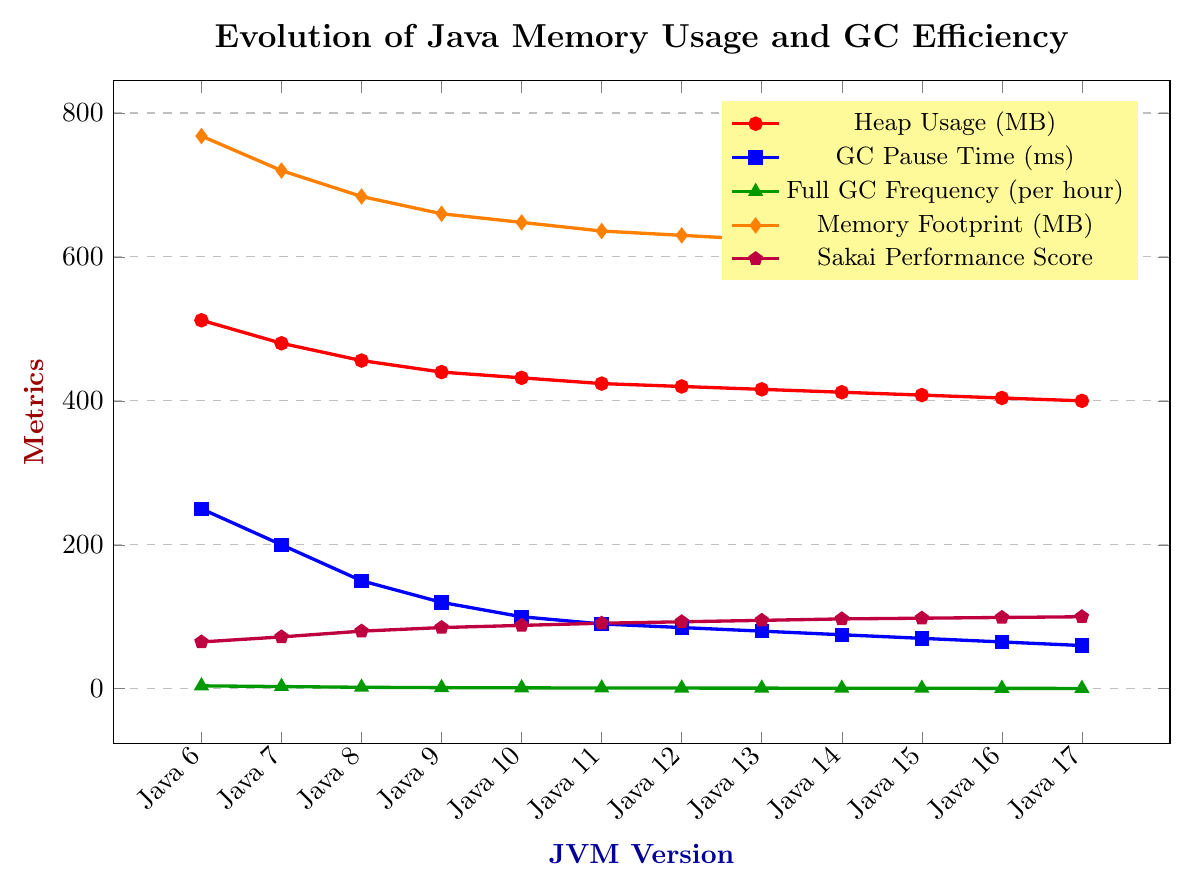What trend can be observed in heap usage across different JVM versions? The heap usage shows a consistent decreasing trend as the JVM version progresses from Java 6 to Java 17.
Answer: Decreasing trend Between which two consecutive JVM versions is the most significant drop in GC Pause Time observed? The most significant drop in GC Pause Time is observed between Java 7 and Java 8, where it decreases from 200 ms to 150 ms.
Answer: Between Java 7 and Java 8 What is the difference in Sakai Performance Score between Java 8 and Java 17? The Sakai Performance Score for Java 8 is 80 and for Java 17 is 100. The difference is 100 - 80 = 20.
Answer: 20 Which JVM version has the highest Full GC Frequency per hour, and what is that frequency? The highest Full GC Frequency per hour is observed in Java 6, which is 4.
Answer: Java 6, 4 How does the Memory Footprint change from Java 6 to Java 17? The Memory Footprint consistently decreases from 768 MB in Java 6 to 600 MB in Java 17.
Answer: Decreases Compare the GC Pause Time for Java 10 and Java 12. Which version has a lower GC Pause Time and by how much? Java 10 has a GC Pause Time of 100 ms and Java 12 has 85 ms. The difference is 100 - 85 = 15 ms, so Java 12 has a lower GC Pause Time by 15 ms.
Answer: Java 12, 15 ms Which metric shows the least variability across JVM versions? By observing the slopes and spread of the lines, Sakai Performance Score shows a smaller and more consistent increment compared to other metrics.
Answer: Sakai Performance Score What is the average heap usage from Java 6 to Java 17? Sum all the heap usage values (512 + 480 + 456 + 440 + 432 + 424 + 420 + 416 + 412 + 408 + 404 + 400) = 5104 MB. There are 12 data points, so the average is 5104 / 12 ≈ 425.33 MB.
Answer: 425.33 MB Identify the JVM version where the Full GC Frequency per hour drops below 1 for the first time. The Full GC Frequency per hour drops below 1 for the first time in Java 11.
Answer: Java 11 